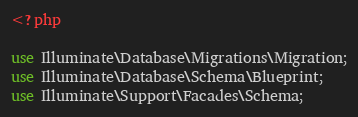Convert code to text. <code><loc_0><loc_0><loc_500><loc_500><_PHP_><?php

use Illuminate\Database\Migrations\Migration;
use Illuminate\Database\Schema\Blueprint;
use Illuminate\Support\Facades\Schema;
</code> 